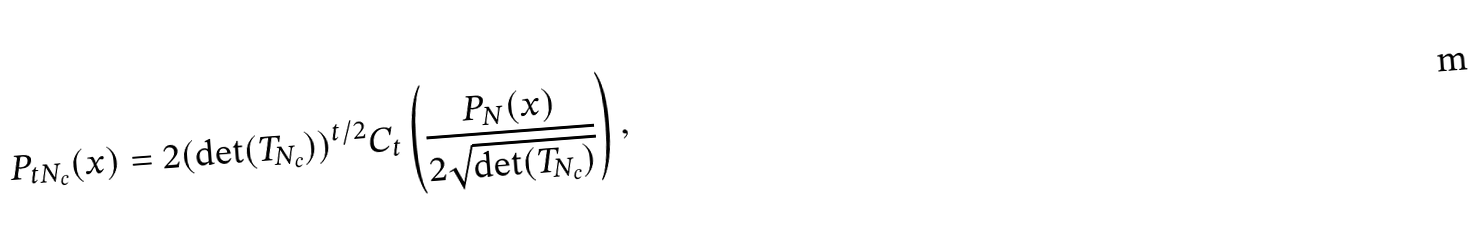<formula> <loc_0><loc_0><loc_500><loc_500>P _ { t N _ { c } } ( x ) = 2 ( \det ( T _ { N _ { c } } ) ) ^ { t / 2 } C _ { t } \left ( \frac { P _ { N } ( x ) } { 2 \sqrt { \det ( T _ { N _ { c } } ) } } \right ) ,</formula> 